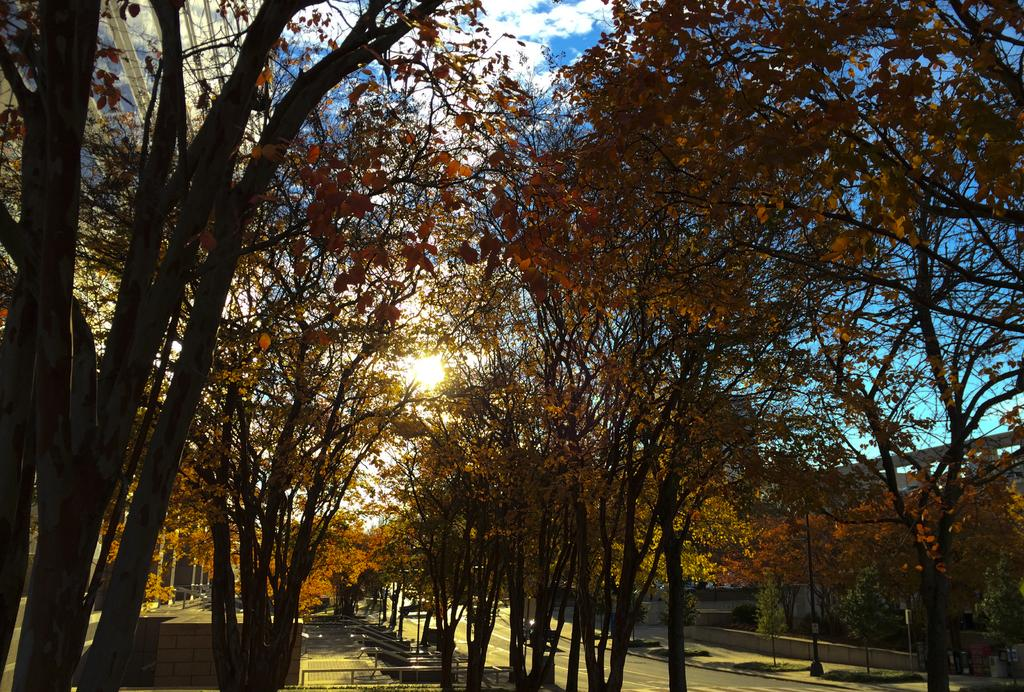What can be seen on the road in the image? There are vehicles on the road in the image. What type of natural elements are present in the image? There are trees in the image. What are the vertical structures in the image? There are poles in the image. What is visible in the background of the image? The sky is visible in the background of the image. What can be seen in the sky in the image? Clouds are present in the sky. What type of celery can be seen growing on the poles in the image? There is no celery present in the image, and celery does not grow on poles. How many caps are visible on the vehicles in the image? There is no mention of caps on the vehicles in the image, so it is impossible to determine their number. 